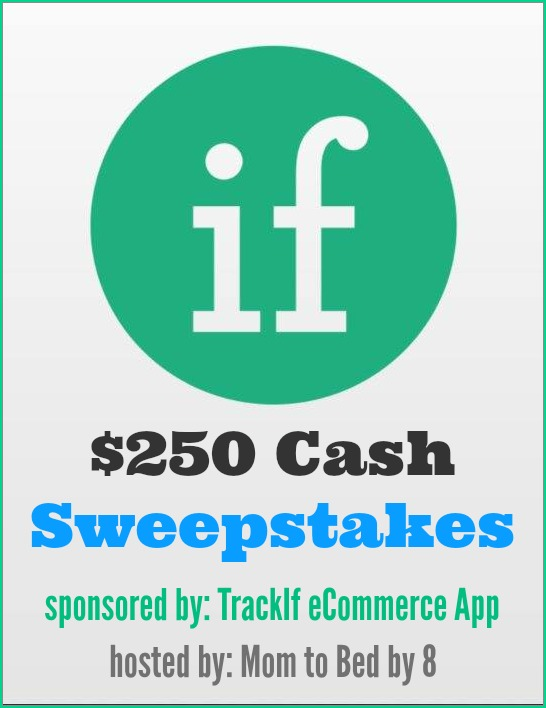What could be the possible relationship between the sponsor and the host mentioned in the advertisement, and how might this partnership benefit both parties involved in the sweepstakes? Based on the advertisement, the sponsor, 'TrackIf eCommerce App,' appears to be a business that provides an app related to tracking and managing eCommerce activities. The host, 'Mom to Bed by 8,' seems to be a blog or platform catering to a family-oriented or parental audience. This suggests a strategic partnership where the sponsor is looking to promote its app to a relevant and engaged audience. The sponsor benefits by gaining exposure to potential customers who are likely to be interested in eCommerce solutions, while the host benefits by offering engaging and valuable content—such as a cash sweepstakes—that attracts and retains its audience. This mutually beneficial arrangement helps the sponsor enhance brand awareness among a targeted demographic, and the host keeps its audience engaged with attractive offers. 